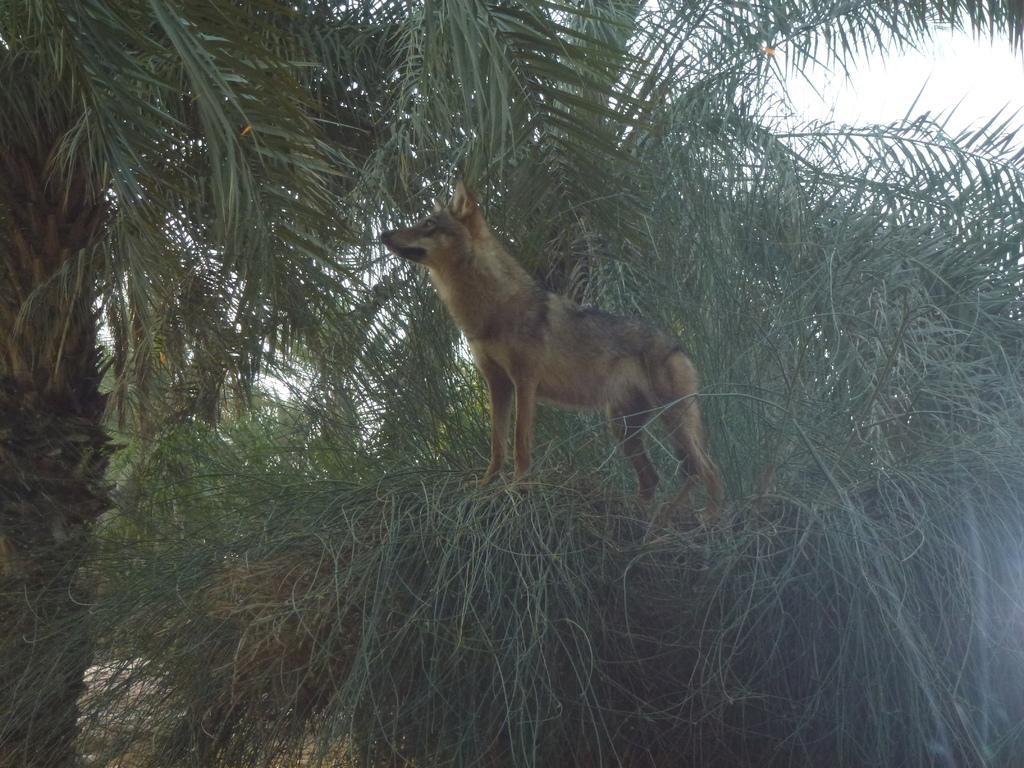What type of animal is present in the image? There is a brown-colored dog in the image. What can be seen in the background of the image? There are trees in the background of the image. What religious symbols can be seen in the image? There are no religious symbols present in the image; it features a brown-colored dog and trees in the background. 